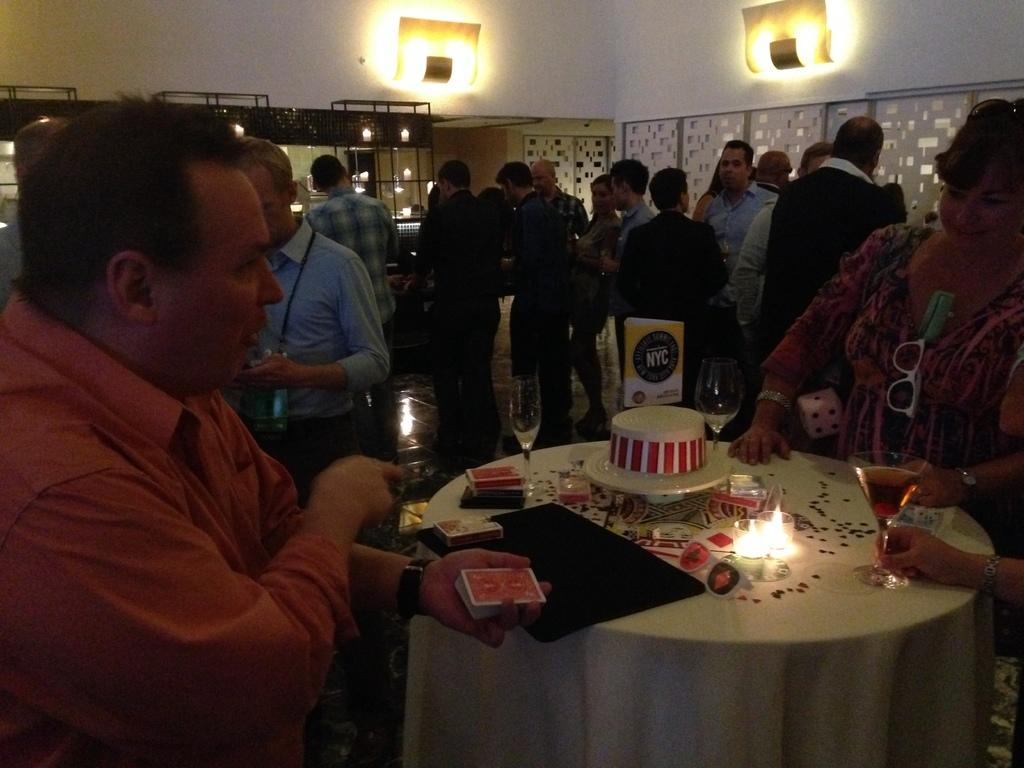What can be seen in the image? There are people standing in the image, including a woman on the right side and a man on the left side. What is on the table in the image? There is a table in the image with candles and a cake on it. Can you describe the table setting? The table has candles on it, which suggests it might be a special occasion or celebration. What type of shop can be seen in the background of the image? There is no shop visible in the image; it only shows people standing around a table with candles and a cake. 